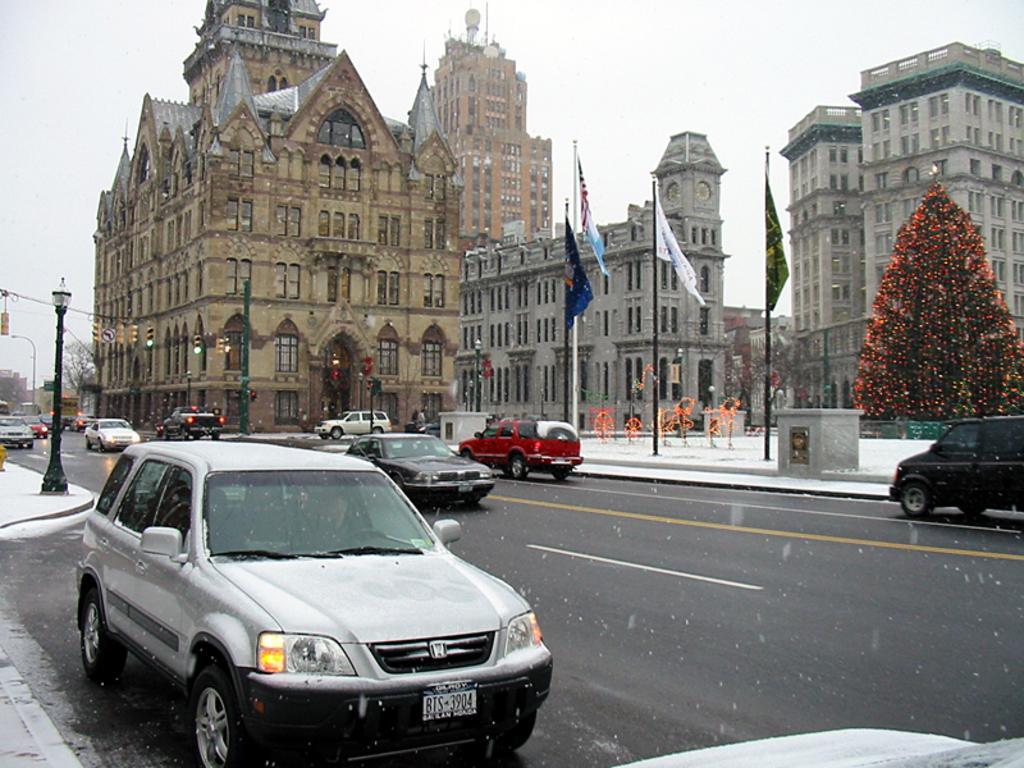Describe this image in one or two sentences. In the foreground of this image, there are vehicles moving on the road. In the background, there is Xmas tree, lights, flags, poles, buildings and the sky. 